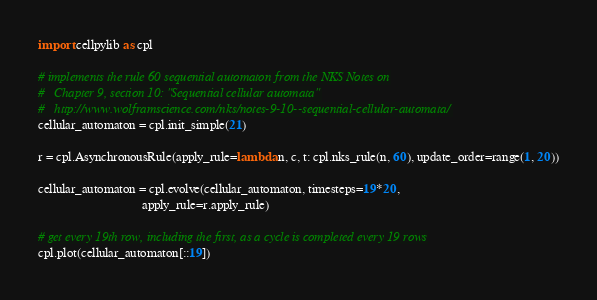<code> <loc_0><loc_0><loc_500><loc_500><_Python_>import cellpylib as cpl

# implements the rule 60 sequential automaton from the NKS Notes on
#   Chapter 9, section 10: "Sequential cellular automata"
#   http://www.wolframscience.com/nks/notes-9-10--sequential-cellular-automata/
cellular_automaton = cpl.init_simple(21)

r = cpl.AsynchronousRule(apply_rule=lambda n, c, t: cpl.nks_rule(n, 60), update_order=range(1, 20))

cellular_automaton = cpl.evolve(cellular_automaton, timesteps=19*20,
                                apply_rule=r.apply_rule)

# get every 19th row, including the first, as a cycle is completed every 19 rows
cpl.plot(cellular_automaton[::19])
</code> 